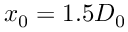<formula> <loc_0><loc_0><loc_500><loc_500>x _ { 0 } = 1 . 5 D _ { 0 }</formula> 